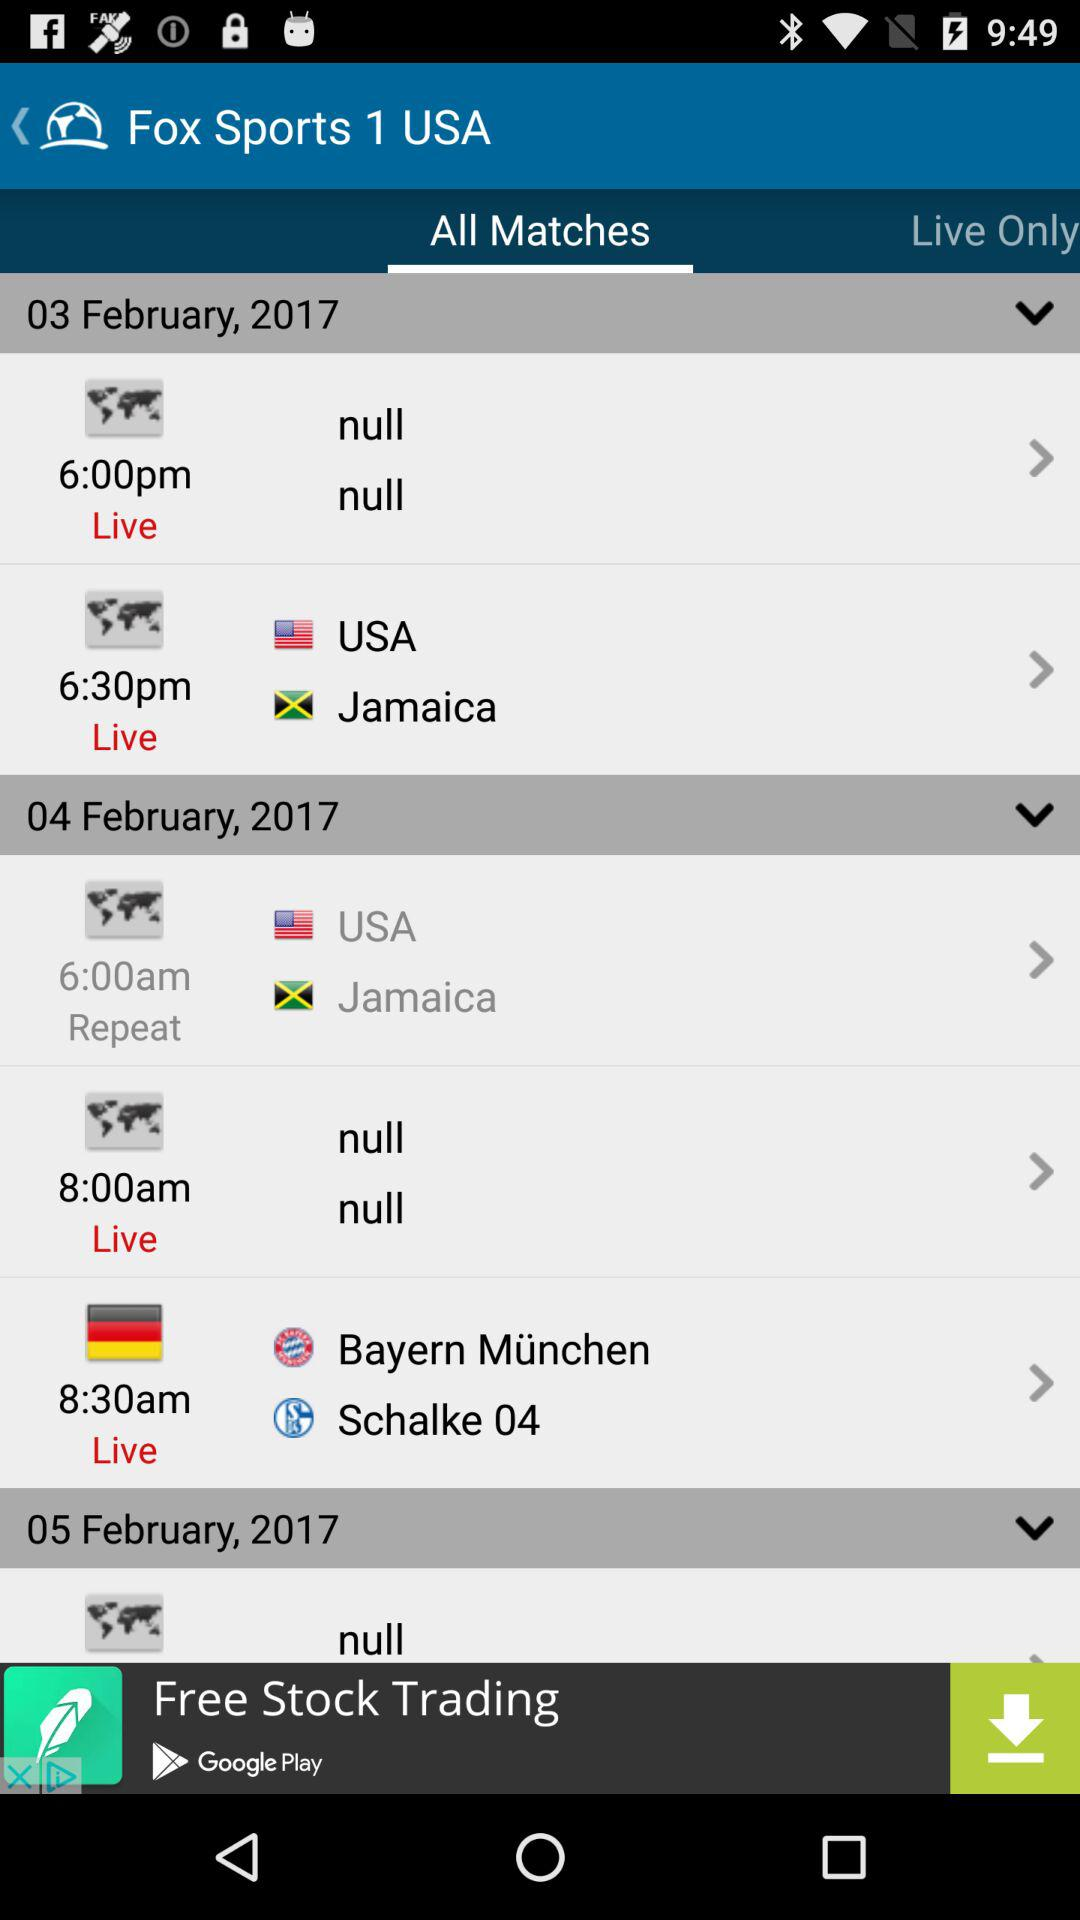When is the live match between the United States and Jamaica scheduled to take place? The live match between the United States and Jamaica is scheduled to take place on February 3, 2017 at 6:30 p.m. 